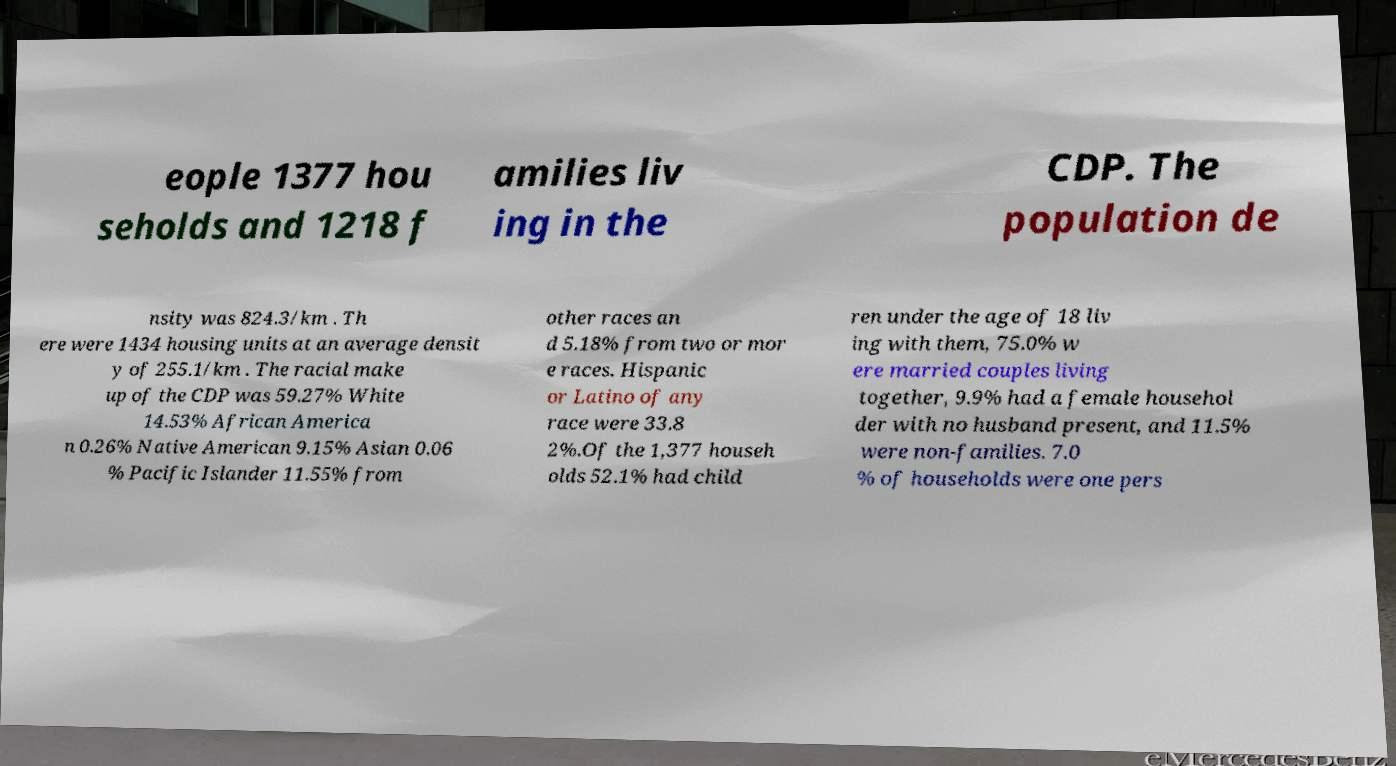Can you read and provide the text displayed in the image?This photo seems to have some interesting text. Can you extract and type it out for me? eople 1377 hou seholds and 1218 f amilies liv ing in the CDP. The population de nsity was 824.3/km . Th ere were 1434 housing units at an average densit y of 255.1/km . The racial make up of the CDP was 59.27% White 14.53% African America n 0.26% Native American 9.15% Asian 0.06 % Pacific Islander 11.55% from other races an d 5.18% from two or mor e races. Hispanic or Latino of any race were 33.8 2%.Of the 1,377 househ olds 52.1% had child ren under the age of 18 liv ing with them, 75.0% w ere married couples living together, 9.9% had a female househol der with no husband present, and 11.5% were non-families. 7.0 % of households were one pers 